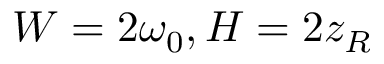<formula> <loc_0><loc_0><loc_500><loc_500>W = 2 \omega _ { 0 } , H = 2 z _ { R }</formula> 